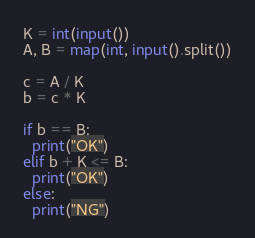Convert code to text. <code><loc_0><loc_0><loc_500><loc_500><_Python_>K = int(input())
A, B = map(int, input().split())

c = A / K
b = c * K

if b == B:
  print("OK")
elif b + K <= B:
  print("OK")
else:
  print("NG")</code> 